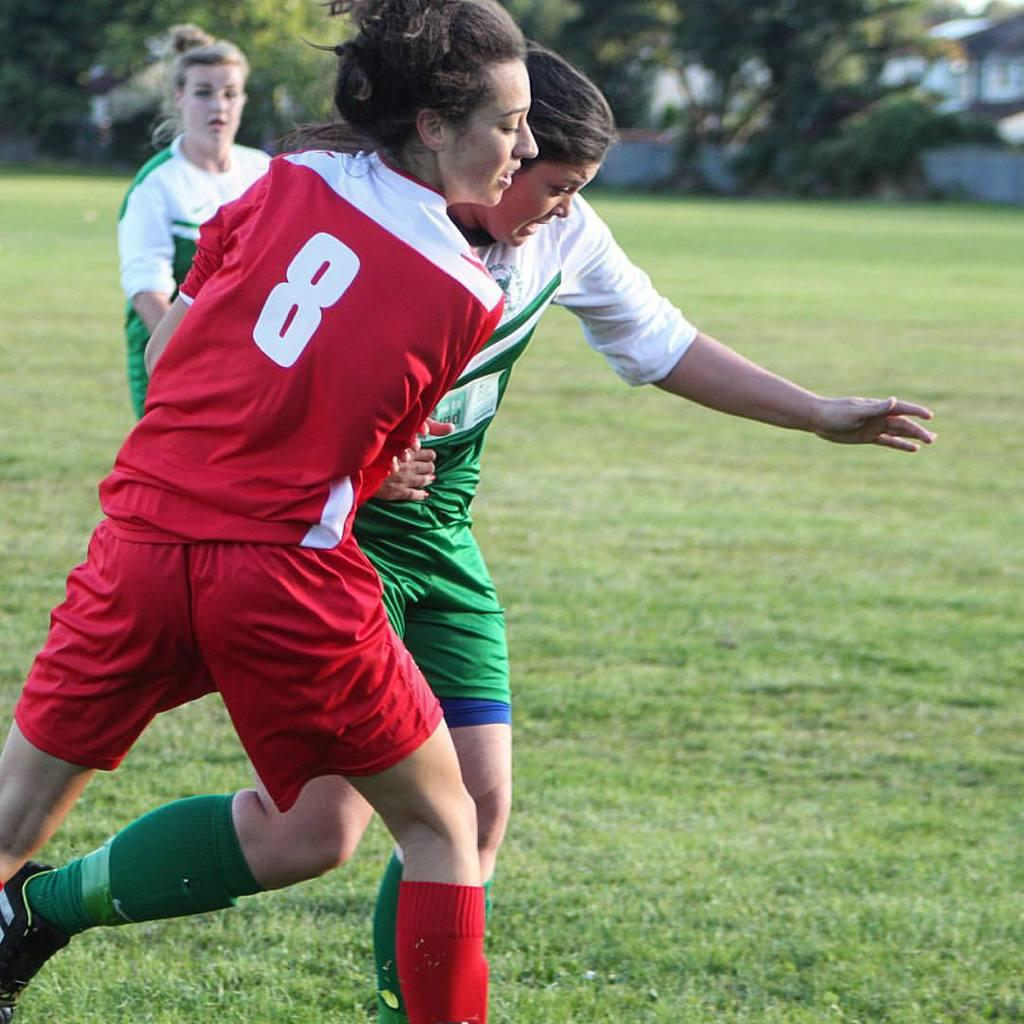<image>
Share a concise interpretation of the image provided. Player number 8 in red fights for the soccer ball. 